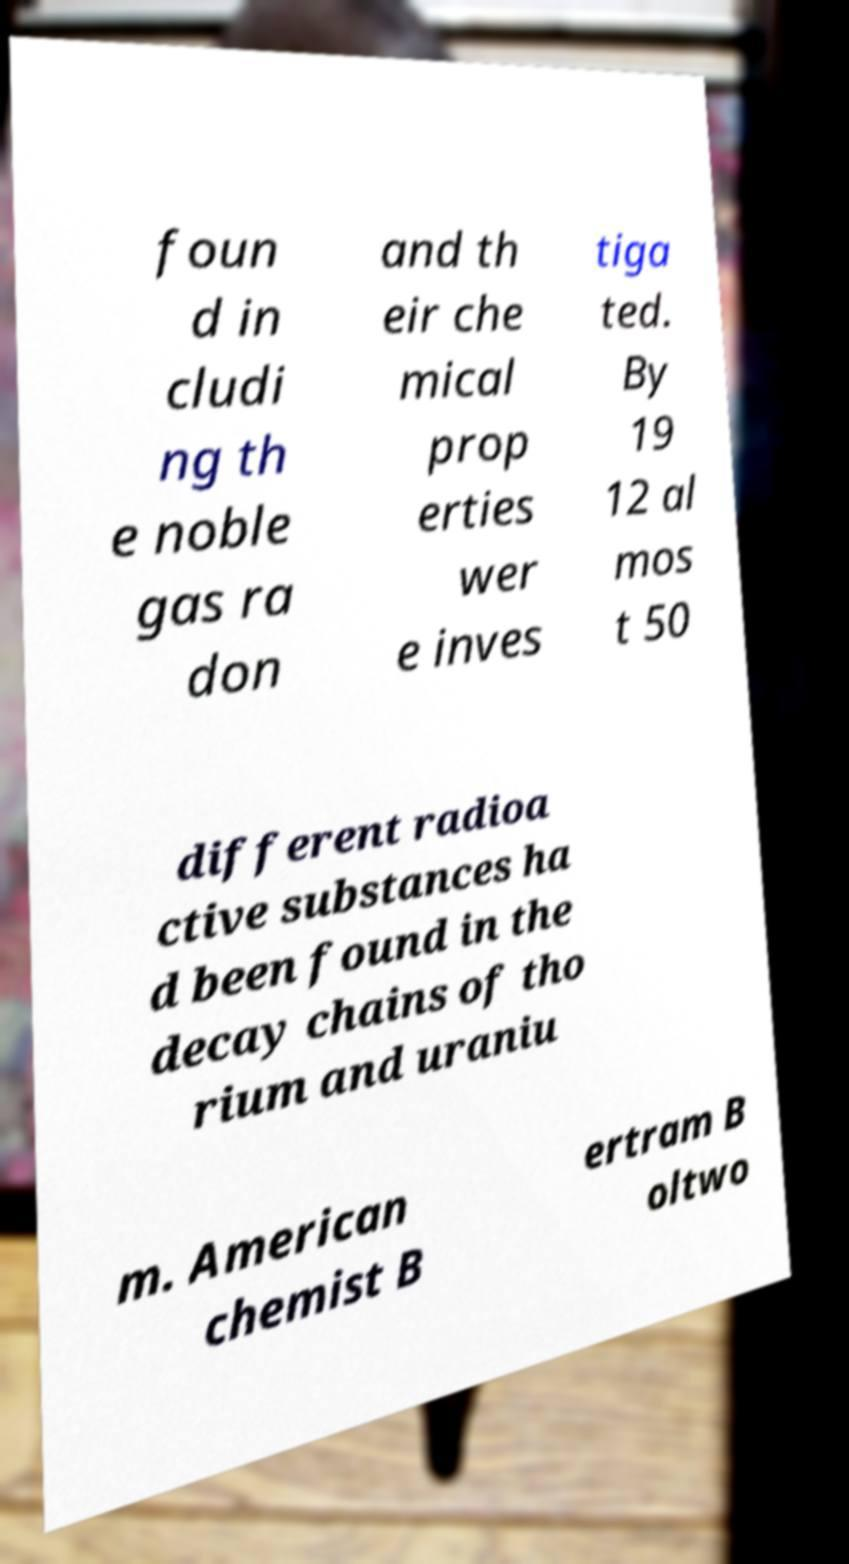Please identify and transcribe the text found in this image. foun d in cludi ng th e noble gas ra don and th eir che mical prop erties wer e inves tiga ted. By 19 12 al mos t 50 different radioa ctive substances ha d been found in the decay chains of tho rium and uraniu m. American chemist B ertram B oltwo 